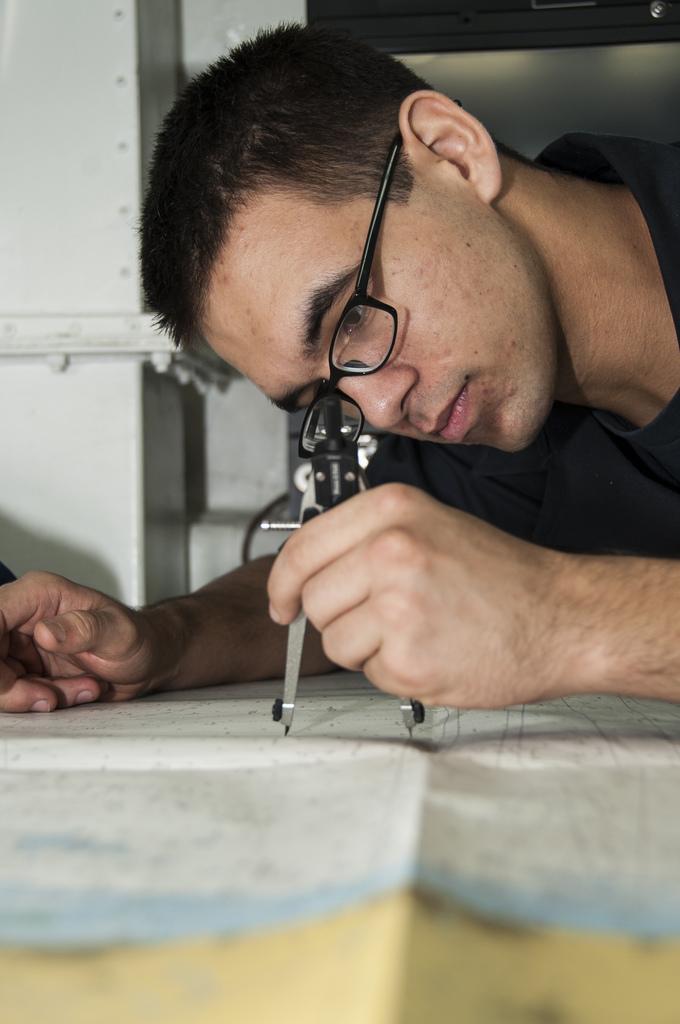Describe this image in one or two sentences. Here we can see a man holding a compass with his hand and he has spectacles. This is a paper. In the background we can see a pillar. 